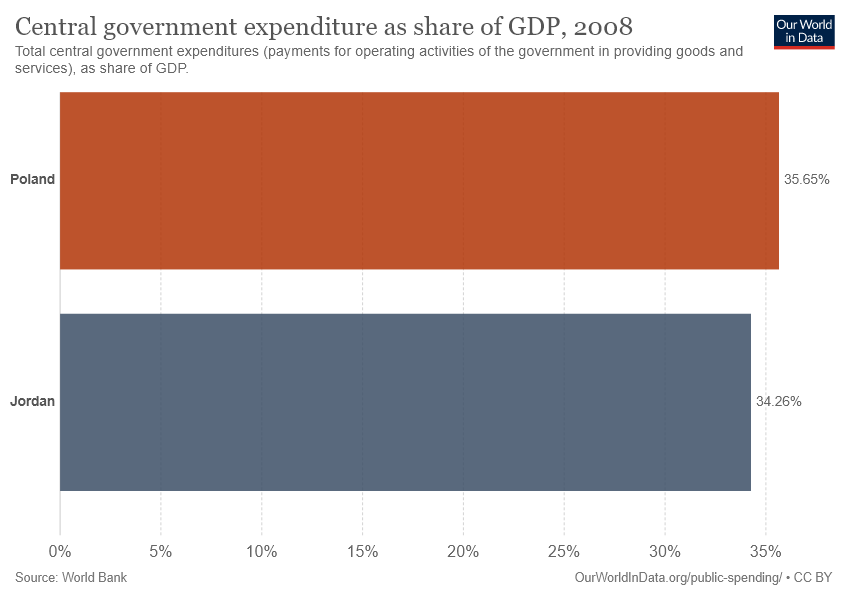What place does the orange bar represent? The orange bar represents Poland, indicating that its central government expenditure was 35.65% of its Gross Domestic Product (GDP) in the year 2008, according to the data from the World Bank. 